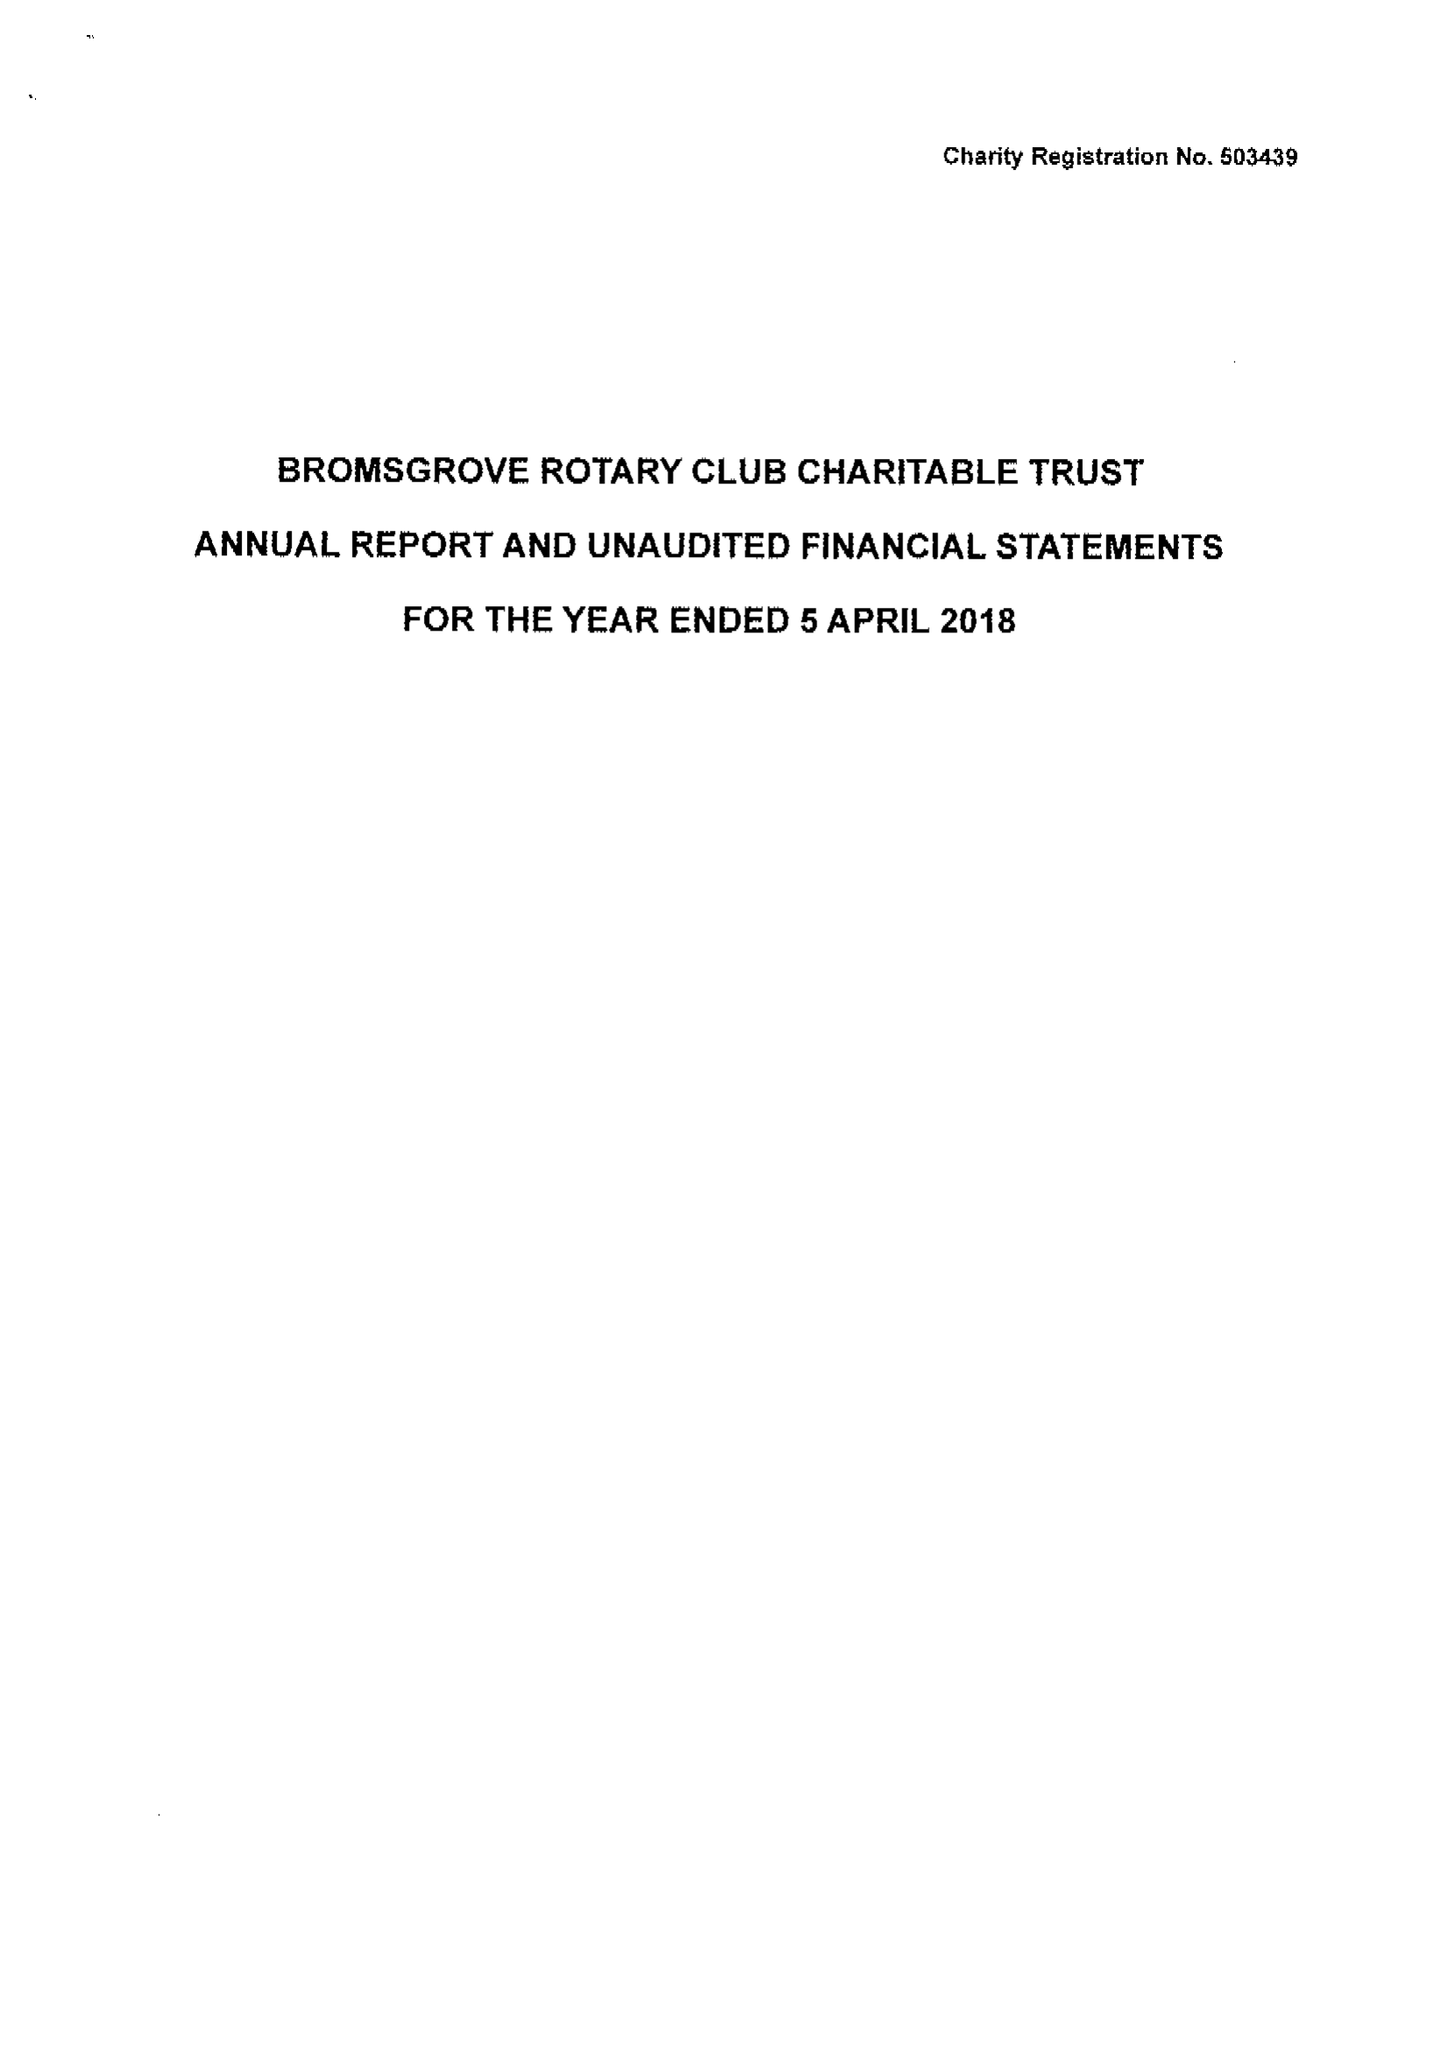What is the value for the spending_annually_in_british_pounds?
Answer the question using a single word or phrase. 36613.00 